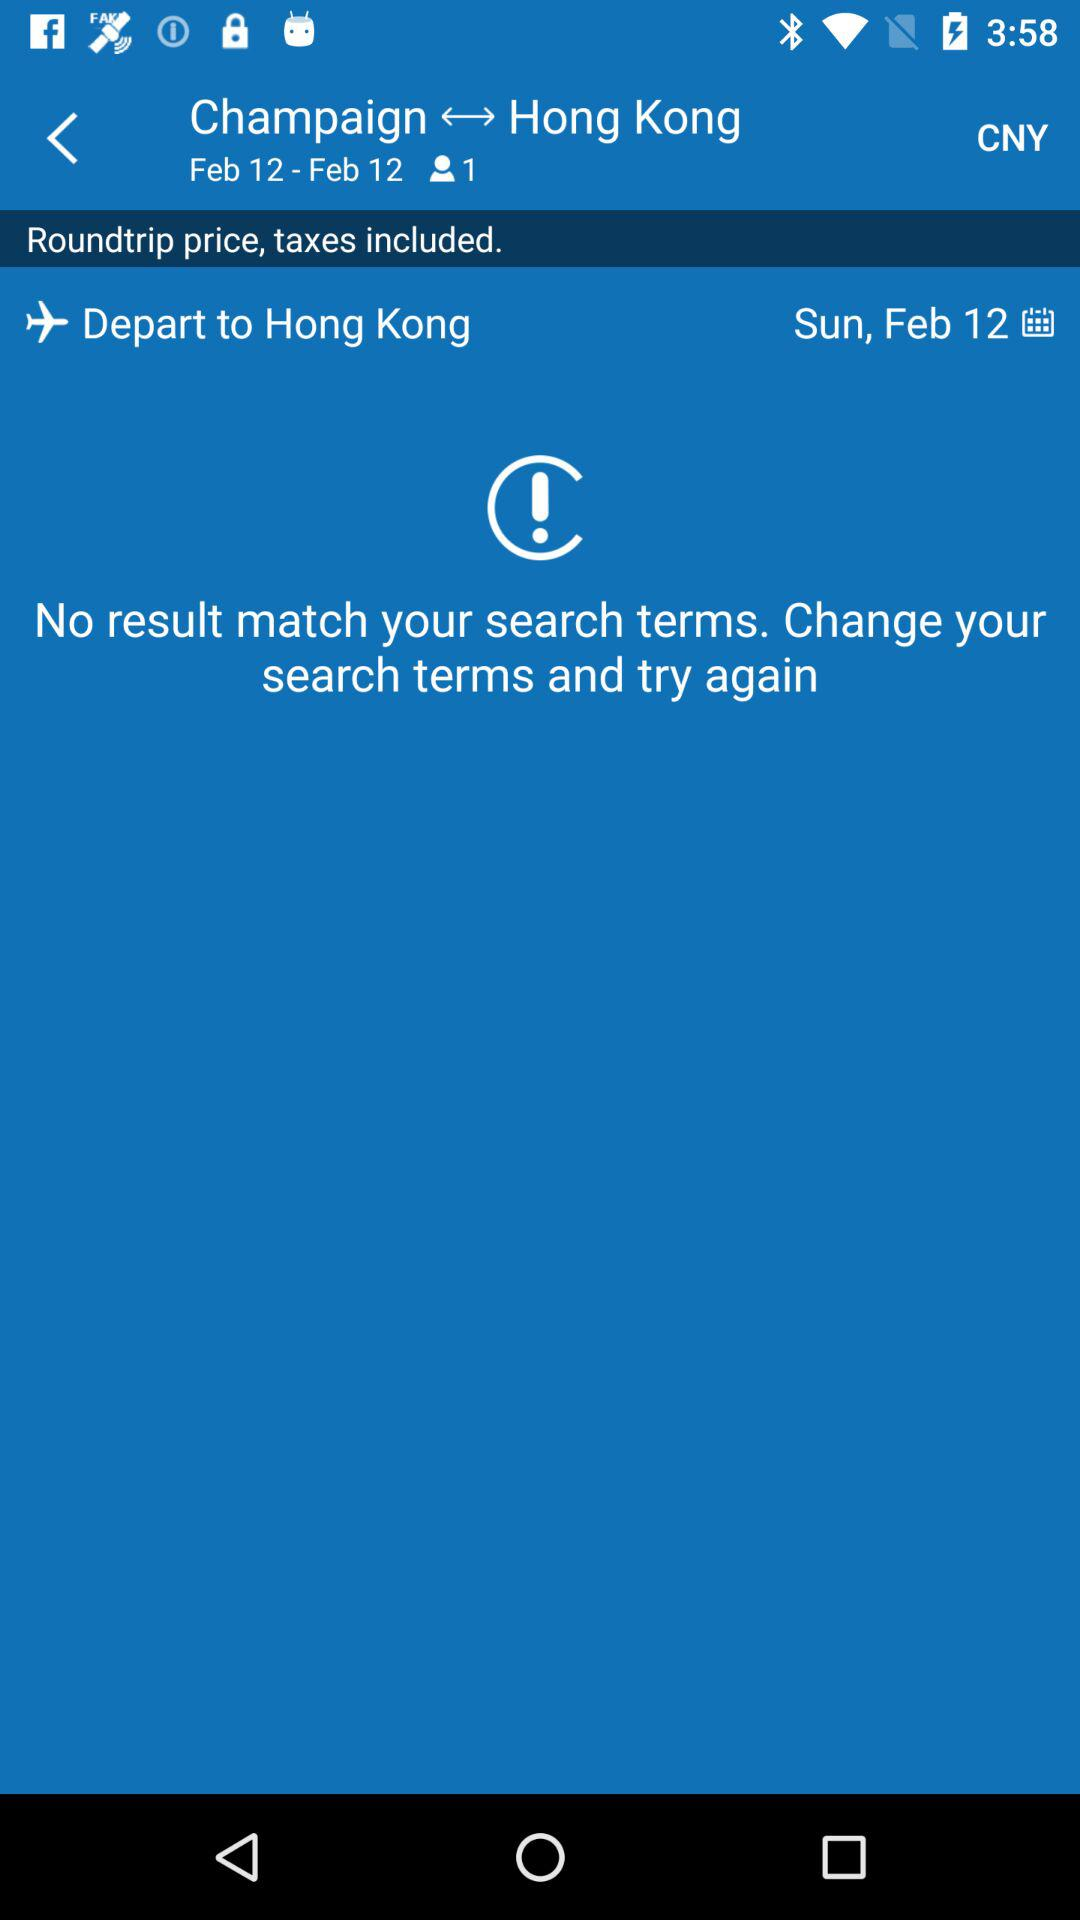What is the date of flight departure to Hong Kong? The date of flight departure to Hong Kong is Sunday, February 12. 